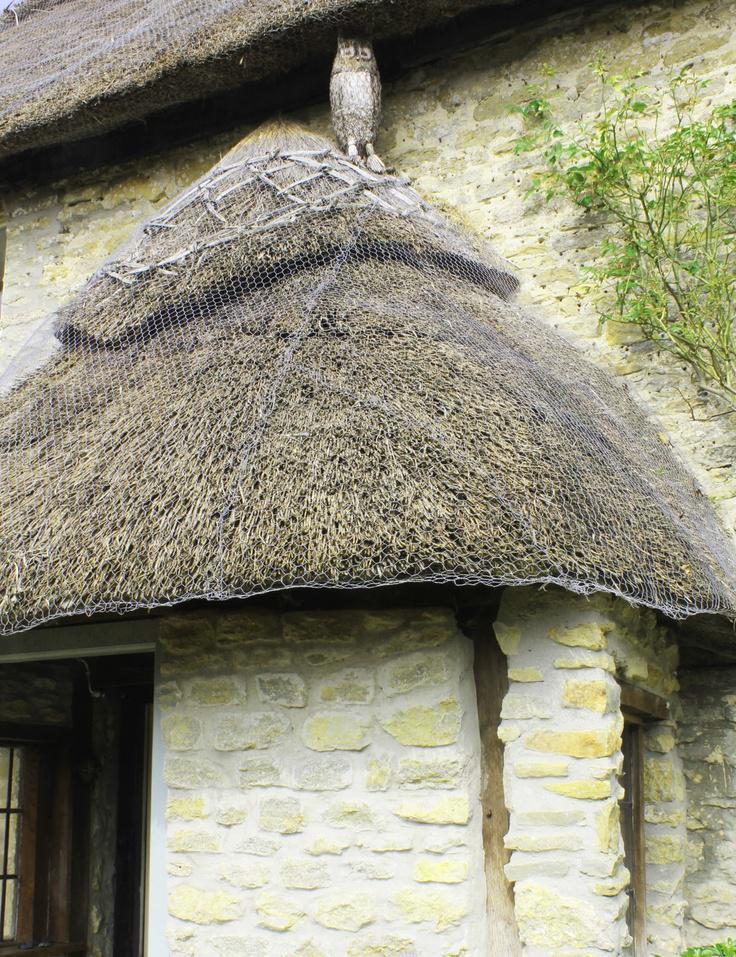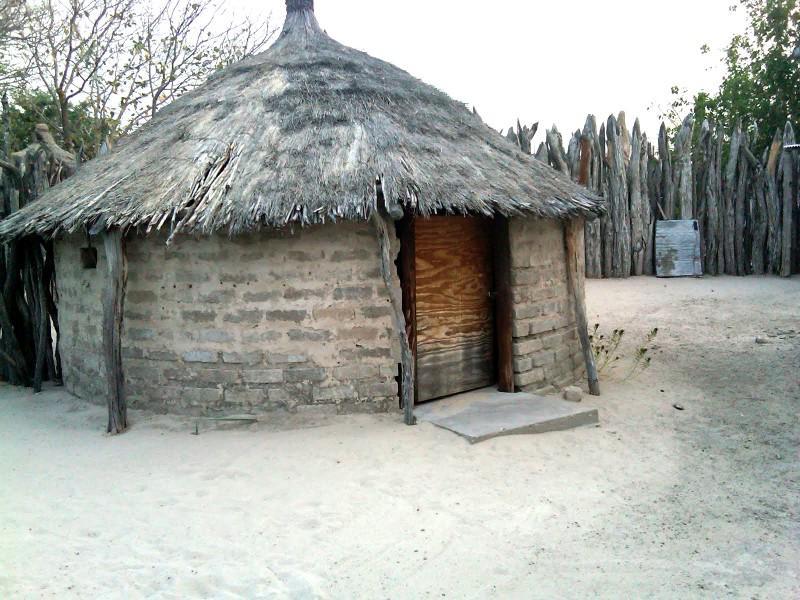The first image is the image on the left, the second image is the image on the right. Analyze the images presented: Is the assertion "The right image shows a left-facing home with two chimneys on a roof that forms at least one overhanging arch over a window." valid? Answer yes or no. No. The first image is the image on the left, the second image is the image on the right. Examine the images to the left and right. Is the description "In at least one image there is a house with a rounded roof and two chimney." accurate? Answer yes or no. No. 